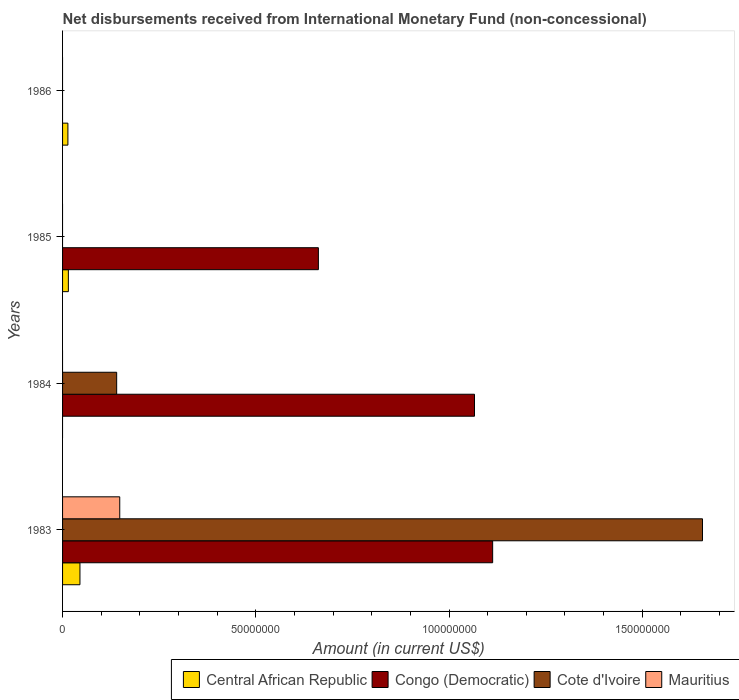How many different coloured bars are there?
Ensure brevity in your answer.  4. What is the amount of disbursements received from International Monetary Fund in Mauritius in 1983?
Offer a very short reply. 1.48e+07. Across all years, what is the maximum amount of disbursements received from International Monetary Fund in Congo (Democratic)?
Your answer should be compact. 1.11e+08. Across all years, what is the minimum amount of disbursements received from International Monetary Fund in Congo (Democratic)?
Your answer should be very brief. 0. What is the total amount of disbursements received from International Monetary Fund in Congo (Democratic) in the graph?
Offer a very short reply. 2.84e+08. What is the difference between the amount of disbursements received from International Monetary Fund in Congo (Democratic) in 1985 and the amount of disbursements received from International Monetary Fund in Mauritius in 1983?
Provide a succinct answer. 5.14e+07. What is the average amount of disbursements received from International Monetary Fund in Mauritius per year?
Give a very brief answer. 3.70e+06. In the year 1984, what is the difference between the amount of disbursements received from International Monetary Fund in Congo (Democratic) and amount of disbursements received from International Monetary Fund in Cote d'Ivoire?
Offer a very short reply. 9.26e+07. What is the ratio of the amount of disbursements received from International Monetary Fund in Cote d'Ivoire in 1983 to that in 1984?
Your response must be concise. 11.83. Is the amount of disbursements received from International Monetary Fund in Cote d'Ivoire in 1983 less than that in 1984?
Your answer should be compact. No. What is the difference between the highest and the lowest amount of disbursements received from International Monetary Fund in Cote d'Ivoire?
Offer a terse response. 1.66e+08. Is it the case that in every year, the sum of the amount of disbursements received from International Monetary Fund in Congo (Democratic) and amount of disbursements received from International Monetary Fund in Mauritius is greater than the sum of amount of disbursements received from International Monetary Fund in Central African Republic and amount of disbursements received from International Monetary Fund in Cote d'Ivoire?
Ensure brevity in your answer.  No. Is it the case that in every year, the sum of the amount of disbursements received from International Monetary Fund in Central African Republic and amount of disbursements received from International Monetary Fund in Cote d'Ivoire is greater than the amount of disbursements received from International Monetary Fund in Congo (Democratic)?
Your response must be concise. No. How many bars are there?
Keep it short and to the point. 9. Are all the bars in the graph horizontal?
Provide a short and direct response. Yes. Where does the legend appear in the graph?
Make the answer very short. Bottom right. How are the legend labels stacked?
Your answer should be compact. Horizontal. What is the title of the graph?
Make the answer very short. Net disbursements received from International Monetary Fund (non-concessional). What is the label or title of the X-axis?
Your answer should be compact. Amount (in current US$). What is the Amount (in current US$) of Central African Republic in 1983?
Offer a very short reply. 4.50e+06. What is the Amount (in current US$) in Congo (Democratic) in 1983?
Give a very brief answer. 1.11e+08. What is the Amount (in current US$) in Cote d'Ivoire in 1983?
Keep it short and to the point. 1.66e+08. What is the Amount (in current US$) of Mauritius in 1983?
Provide a succinct answer. 1.48e+07. What is the Amount (in current US$) of Central African Republic in 1984?
Provide a short and direct response. 0. What is the Amount (in current US$) of Congo (Democratic) in 1984?
Give a very brief answer. 1.07e+08. What is the Amount (in current US$) in Cote d'Ivoire in 1984?
Provide a succinct answer. 1.40e+07. What is the Amount (in current US$) of Mauritius in 1984?
Your answer should be compact. 0. What is the Amount (in current US$) in Central African Republic in 1985?
Make the answer very short. 1.50e+06. What is the Amount (in current US$) in Congo (Democratic) in 1985?
Make the answer very short. 6.62e+07. What is the Amount (in current US$) in Cote d'Ivoire in 1985?
Offer a terse response. 0. What is the Amount (in current US$) of Mauritius in 1985?
Provide a succinct answer. 0. What is the Amount (in current US$) in Central African Republic in 1986?
Provide a short and direct response. 1.38e+06. Across all years, what is the maximum Amount (in current US$) of Central African Republic?
Keep it short and to the point. 4.50e+06. Across all years, what is the maximum Amount (in current US$) of Congo (Democratic)?
Provide a succinct answer. 1.11e+08. Across all years, what is the maximum Amount (in current US$) in Cote d'Ivoire?
Provide a succinct answer. 1.66e+08. Across all years, what is the maximum Amount (in current US$) of Mauritius?
Provide a succinct answer. 1.48e+07. Across all years, what is the minimum Amount (in current US$) of Cote d'Ivoire?
Your response must be concise. 0. What is the total Amount (in current US$) of Central African Republic in the graph?
Provide a short and direct response. 7.38e+06. What is the total Amount (in current US$) in Congo (Democratic) in the graph?
Make the answer very short. 2.84e+08. What is the total Amount (in current US$) in Cote d'Ivoire in the graph?
Offer a very short reply. 1.80e+08. What is the total Amount (in current US$) of Mauritius in the graph?
Ensure brevity in your answer.  1.48e+07. What is the difference between the Amount (in current US$) in Congo (Democratic) in 1983 and that in 1984?
Your response must be concise. 4.70e+06. What is the difference between the Amount (in current US$) in Cote d'Ivoire in 1983 and that in 1984?
Ensure brevity in your answer.  1.52e+08. What is the difference between the Amount (in current US$) in Central African Republic in 1983 and that in 1985?
Provide a short and direct response. 3.00e+06. What is the difference between the Amount (in current US$) in Congo (Democratic) in 1983 and that in 1985?
Provide a succinct answer. 4.51e+07. What is the difference between the Amount (in current US$) of Central African Republic in 1983 and that in 1986?
Provide a short and direct response. 3.12e+06. What is the difference between the Amount (in current US$) of Congo (Democratic) in 1984 and that in 1985?
Your response must be concise. 4.04e+07. What is the difference between the Amount (in current US$) of Central African Republic in 1985 and that in 1986?
Offer a terse response. 1.20e+05. What is the difference between the Amount (in current US$) in Central African Republic in 1983 and the Amount (in current US$) in Congo (Democratic) in 1984?
Make the answer very short. -1.02e+08. What is the difference between the Amount (in current US$) of Central African Republic in 1983 and the Amount (in current US$) of Cote d'Ivoire in 1984?
Provide a succinct answer. -9.50e+06. What is the difference between the Amount (in current US$) in Congo (Democratic) in 1983 and the Amount (in current US$) in Cote d'Ivoire in 1984?
Provide a short and direct response. 9.73e+07. What is the difference between the Amount (in current US$) of Central African Republic in 1983 and the Amount (in current US$) of Congo (Democratic) in 1985?
Your answer should be compact. -6.17e+07. What is the average Amount (in current US$) of Central African Republic per year?
Provide a succinct answer. 1.84e+06. What is the average Amount (in current US$) of Congo (Democratic) per year?
Give a very brief answer. 7.10e+07. What is the average Amount (in current US$) in Cote d'Ivoire per year?
Your answer should be compact. 4.49e+07. What is the average Amount (in current US$) of Mauritius per year?
Your response must be concise. 3.70e+06. In the year 1983, what is the difference between the Amount (in current US$) in Central African Republic and Amount (in current US$) in Congo (Democratic)?
Your answer should be compact. -1.07e+08. In the year 1983, what is the difference between the Amount (in current US$) in Central African Republic and Amount (in current US$) in Cote d'Ivoire?
Ensure brevity in your answer.  -1.61e+08. In the year 1983, what is the difference between the Amount (in current US$) of Central African Republic and Amount (in current US$) of Mauritius?
Give a very brief answer. -1.03e+07. In the year 1983, what is the difference between the Amount (in current US$) of Congo (Democratic) and Amount (in current US$) of Cote d'Ivoire?
Your answer should be compact. -5.43e+07. In the year 1983, what is the difference between the Amount (in current US$) in Congo (Democratic) and Amount (in current US$) in Mauritius?
Your response must be concise. 9.65e+07. In the year 1983, what is the difference between the Amount (in current US$) of Cote d'Ivoire and Amount (in current US$) of Mauritius?
Your answer should be very brief. 1.51e+08. In the year 1984, what is the difference between the Amount (in current US$) in Congo (Democratic) and Amount (in current US$) in Cote d'Ivoire?
Give a very brief answer. 9.26e+07. In the year 1985, what is the difference between the Amount (in current US$) of Central African Republic and Amount (in current US$) of Congo (Democratic)?
Provide a succinct answer. -6.47e+07. What is the ratio of the Amount (in current US$) of Congo (Democratic) in 1983 to that in 1984?
Provide a succinct answer. 1.04. What is the ratio of the Amount (in current US$) of Cote d'Ivoire in 1983 to that in 1984?
Provide a short and direct response. 11.83. What is the ratio of the Amount (in current US$) of Central African Republic in 1983 to that in 1985?
Make the answer very short. 3. What is the ratio of the Amount (in current US$) of Congo (Democratic) in 1983 to that in 1985?
Your response must be concise. 1.68. What is the ratio of the Amount (in current US$) of Central African Republic in 1983 to that in 1986?
Provide a short and direct response. 3.26. What is the ratio of the Amount (in current US$) in Congo (Democratic) in 1984 to that in 1985?
Offer a very short reply. 1.61. What is the ratio of the Amount (in current US$) in Central African Republic in 1985 to that in 1986?
Your answer should be very brief. 1.09. What is the difference between the highest and the second highest Amount (in current US$) of Congo (Democratic)?
Provide a short and direct response. 4.70e+06. What is the difference between the highest and the lowest Amount (in current US$) of Central African Republic?
Offer a very short reply. 4.50e+06. What is the difference between the highest and the lowest Amount (in current US$) in Congo (Democratic)?
Your answer should be very brief. 1.11e+08. What is the difference between the highest and the lowest Amount (in current US$) of Cote d'Ivoire?
Offer a terse response. 1.66e+08. What is the difference between the highest and the lowest Amount (in current US$) of Mauritius?
Ensure brevity in your answer.  1.48e+07. 